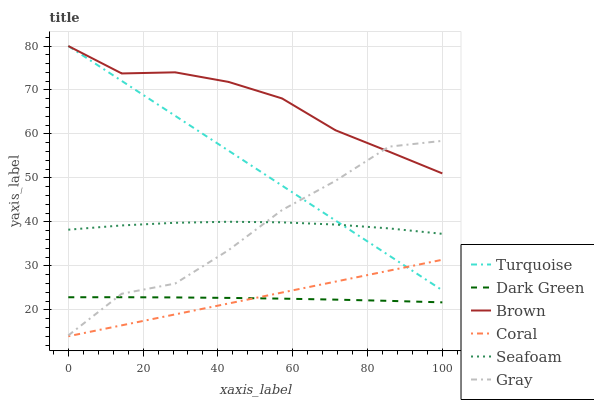Does Turquoise have the minimum area under the curve?
Answer yes or no. No. Does Turquoise have the maximum area under the curve?
Answer yes or no. No. Is Gray the smoothest?
Answer yes or no. No. Is Turquoise the roughest?
Answer yes or no. No. Does Turquoise have the lowest value?
Answer yes or no. No. Does Gray have the highest value?
Answer yes or no. No. Is Dark Green less than Turquoise?
Answer yes or no. Yes. Is Brown greater than Coral?
Answer yes or no. Yes. Does Dark Green intersect Turquoise?
Answer yes or no. No. 